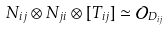Convert formula to latex. <formula><loc_0><loc_0><loc_500><loc_500>N _ { i j } \otimes N _ { j i } \otimes [ T _ { i j } ] \simeq \mathcal { O } _ { D _ { i j } }</formula> 